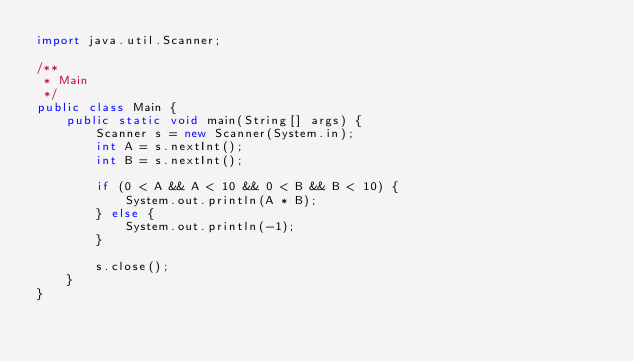Convert code to text. <code><loc_0><loc_0><loc_500><loc_500><_Java_>import java.util.Scanner;

/**
 * Main
 */
public class Main {
    public static void main(String[] args) {
        Scanner s = new Scanner(System.in);
        int A = s.nextInt();
        int B = s.nextInt();

        if (0 < A && A < 10 && 0 < B && B < 10) {
            System.out.println(A * B);
        } else {
            System.out.println(-1);
        }

        s.close();
    }
}</code> 